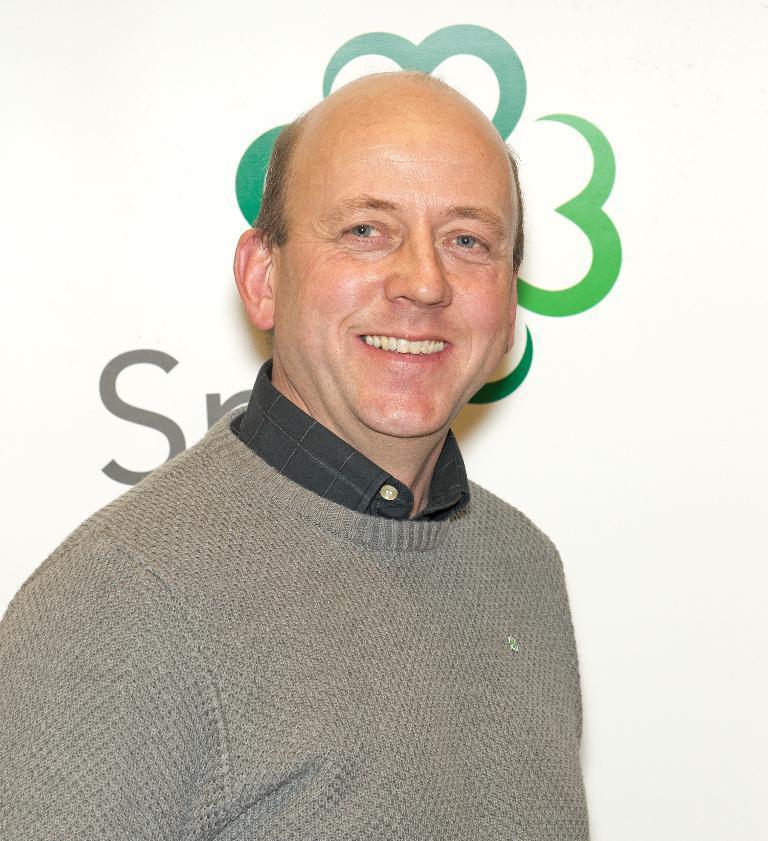How would you summarize this image in a sentence or two? This image consists of a man wearing gray color T-shirt. In the background, there is a banner. 